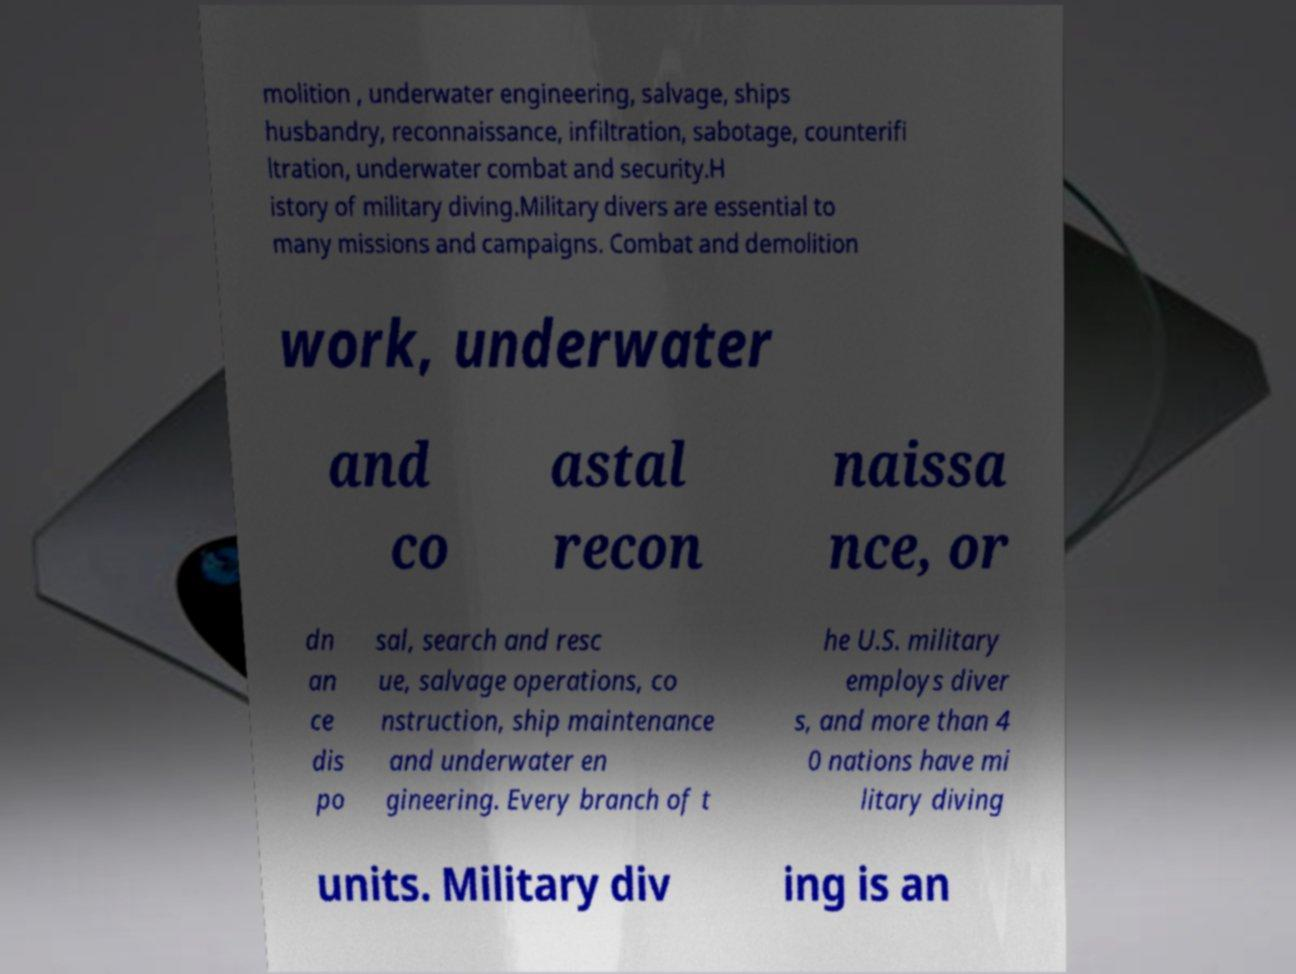Can you read and provide the text displayed in the image?This photo seems to have some interesting text. Can you extract and type it out for me? molition , underwater engineering, salvage, ships husbandry, reconnaissance, infiltration, sabotage, counterifi ltration, underwater combat and security.H istory of military diving.Military divers are essential to many missions and campaigns. Combat and demolition work, underwater and co astal recon naissa nce, or dn an ce dis po sal, search and resc ue, salvage operations, co nstruction, ship maintenance and underwater en gineering. Every branch of t he U.S. military employs diver s, and more than 4 0 nations have mi litary diving units. Military div ing is an 